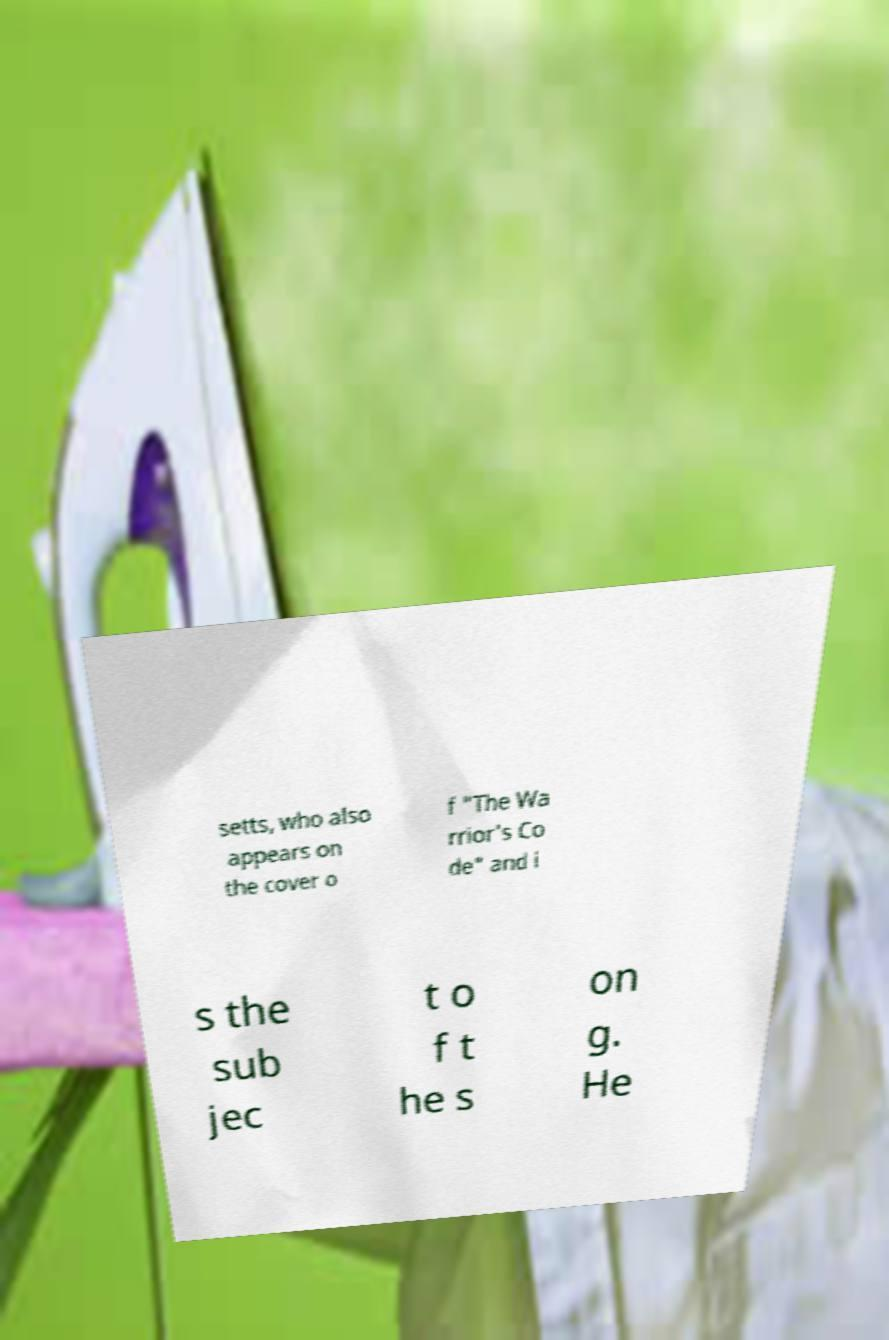There's text embedded in this image that I need extracted. Can you transcribe it verbatim? setts, who also appears on the cover o f "The Wa rrior's Co de" and i s the sub jec t o f t he s on g. He 